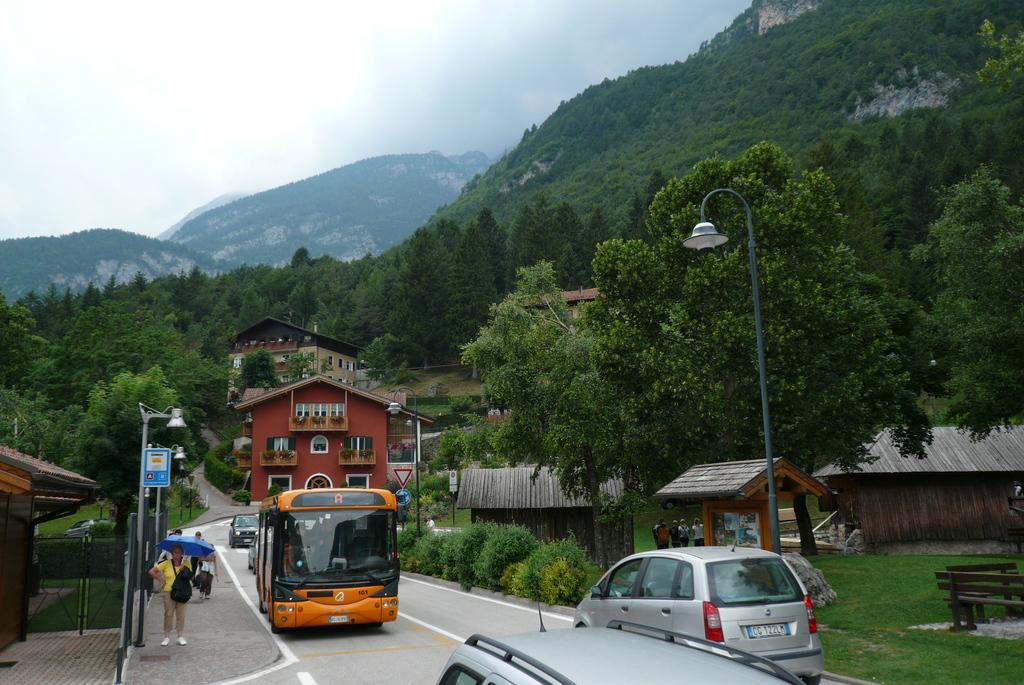Could you give a brief overview of what you see in this image? In this image, we can see a bus and some cars on the road. On the left, there is a lady standing and holding an umbrella and she is wearing a bag. On the left, there is a bench and in the background, there are trees, buildings,sheds, poles, name boards and sign boards. 